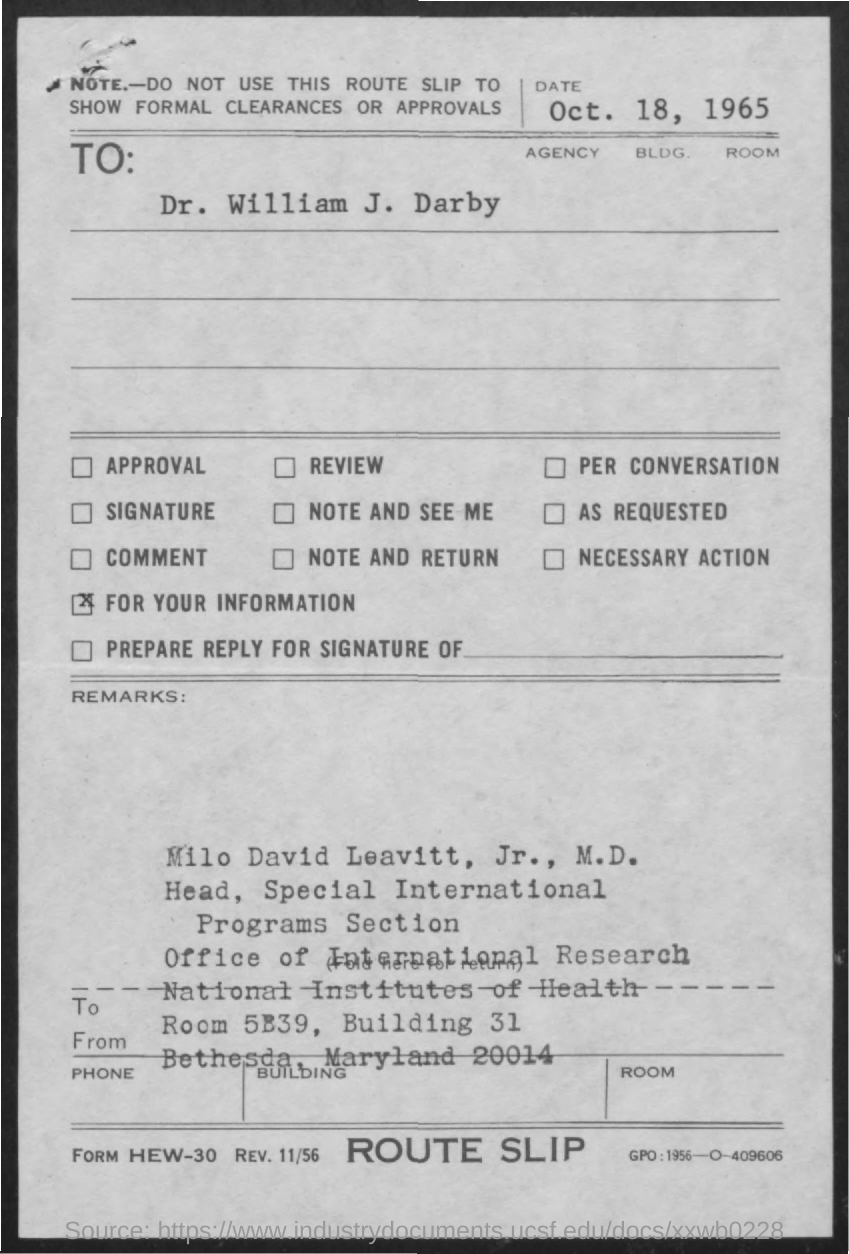Identify some key points in this picture. This letter is addressed to Dr. William J. Darby. The date on the document is October 18, 1965. 